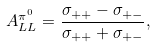<formula> <loc_0><loc_0><loc_500><loc_500>A _ { L L } ^ { \pi ^ { 0 } } = \frac { \sigma _ { + + } - \sigma _ { + - } } { \sigma _ { + + } + \sigma _ { + - } } ,</formula> 